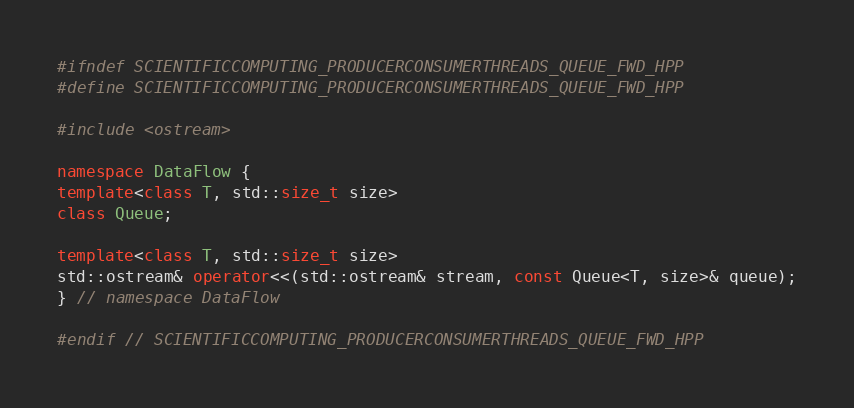<code> <loc_0><loc_0><loc_500><loc_500><_C++_>#ifndef SCIENTIFICCOMPUTING_PRODUCERCONSUMERTHREADS_QUEUE_FWD_HPP
#define SCIENTIFICCOMPUTING_PRODUCERCONSUMERTHREADS_QUEUE_FWD_HPP

#include <ostream>

namespace DataFlow {
template<class T, std::size_t size>
class Queue;

template<class T, std::size_t size>
std::ostream& operator<<(std::ostream& stream, const Queue<T, size>& queue);
} // namespace DataFlow

#endif // SCIENTIFICCOMPUTING_PRODUCERCONSUMERTHREADS_QUEUE_FWD_HPP
</code> 